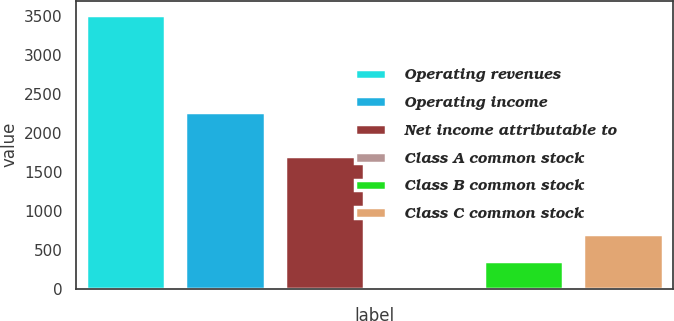Convert chart to OTSL. <chart><loc_0><loc_0><loc_500><loc_500><bar_chart><fcel>Operating revenues<fcel>Operating income<fcel>Net income attributable to<fcel>Class A common stock<fcel>Class B common stock<fcel>Class C common stock<nl><fcel>3518<fcel>2262<fcel>1697<fcel>0.69<fcel>352.42<fcel>704.15<nl></chart> 